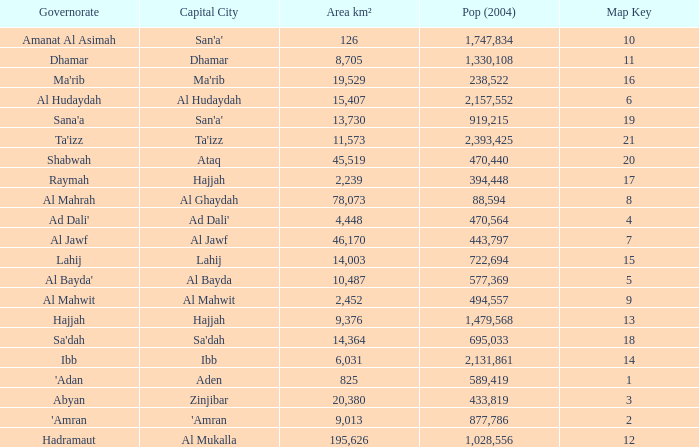I'm looking to parse the entire table for insights. Could you assist me with that? {'header': ['Governorate', 'Capital City', 'Area km²', 'Pop (2004)', 'Map Key'], 'rows': [['Amanat Al Asimah', "San'a'", '126', '1,747,834', '10'], ['Dhamar', 'Dhamar', '8,705', '1,330,108', '11'], ["Ma'rib", "Ma'rib", '19,529', '238,522', '16'], ['Al Hudaydah', 'Al Hudaydah', '15,407', '2,157,552', '6'], ["Sana'a", "San'a'", '13,730', '919,215', '19'], ["Ta'izz", "Ta'izz", '11,573', '2,393,425', '21'], ['Shabwah', 'Ataq', '45,519', '470,440', '20'], ['Raymah', 'Hajjah', '2,239', '394,448', '17'], ['Al Mahrah', 'Al Ghaydah', '78,073', '88,594', '8'], ["Ad Dali'", "Ad Dali'", '4,448', '470,564', '4'], ['Al Jawf', 'Al Jawf', '46,170', '443,797', '7'], ['Lahij', 'Lahij', '14,003', '722,694', '15'], ["Al Bayda'", 'Al Bayda', '10,487', '577,369', '5'], ['Al Mahwit', 'Al Mahwit', '2,452', '494,557', '9'], ['Hajjah', 'Hajjah', '9,376', '1,479,568', '13'], ["Sa'dah", "Sa'dah", '14,364', '695,033', '18'], ['Ibb', 'Ibb', '6,031', '2,131,861', '14'], ["'Adan", 'Aden', '825', '589,419', '1'], ['Abyan', 'Zinjibar', '20,380', '433,819', '3'], ["'Amran", "'Amran", '9,013', '877,786', '2'], ['Hadramaut', 'Al Mukalla', '195,626', '1,028,556', '12']]} Count the sum of Pop (2004) which has a Governorate of al mahrah with an Area km² smaller than 78,073? None. 